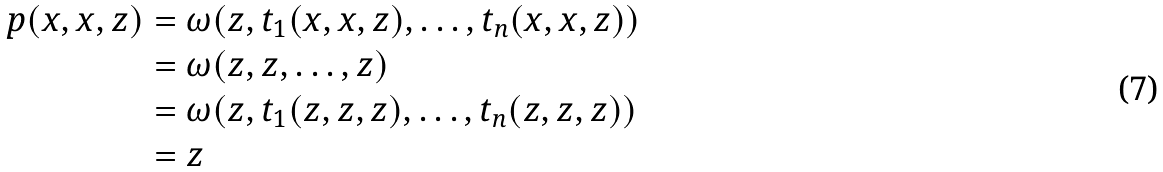Convert formula to latex. <formula><loc_0><loc_0><loc_500><loc_500>p ( x , x , z ) & = \omega ( z , t _ { 1 } ( x , x , z ) , \dots , t _ { n } ( x , x , z ) ) \\ & = \omega ( z , z , \dots , z ) \\ & = \omega ( z , t _ { 1 } ( z , z , z ) , \dots , t _ { n } ( z , z , z ) ) \\ & = z</formula> 